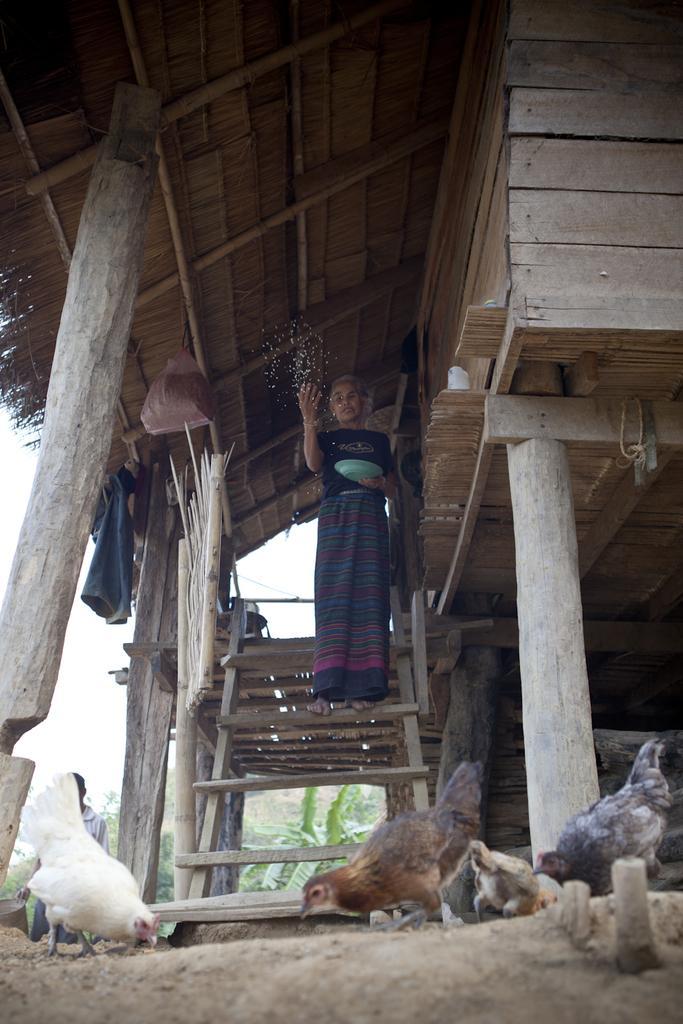How would you summarize this image in a sentence or two? In this image we can see hens on the ground, wooden house, persons standing and one of them is holding a serving plate in the hands, clothes hanged to the sticks, trees and sky. 